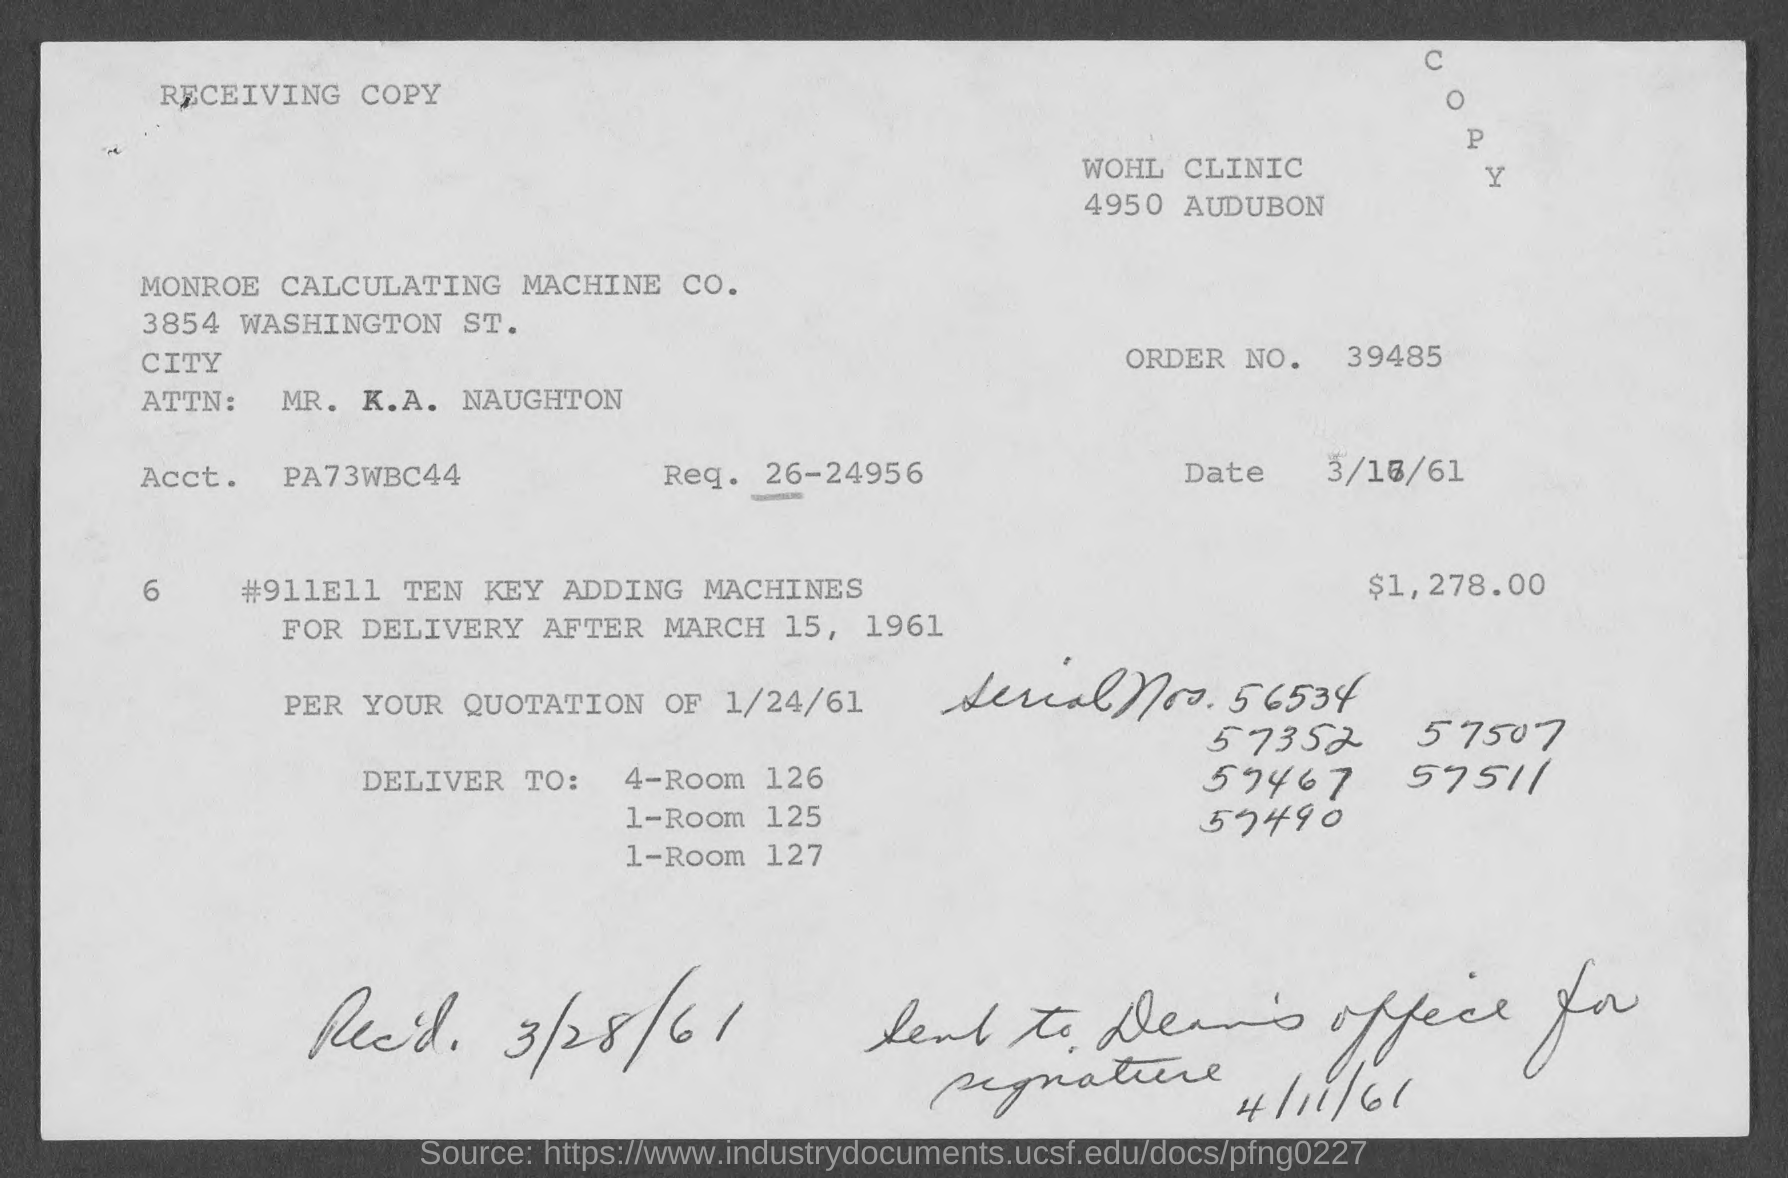What is the order no. mentioned in the given page ?
Provide a succinct answer. 39485. What is the amount mentioned in the given form ?
Make the answer very short. $ 1,278.00. What is the acct. mentioned in the given form ?
Keep it short and to the point. PA73WBC44. What is the req. mentioned in the given form ?
Your answer should be compact. 26-24956. What is the rec'd date mentioned in the given page ?
Your answer should be very brief. 3/28/61. 